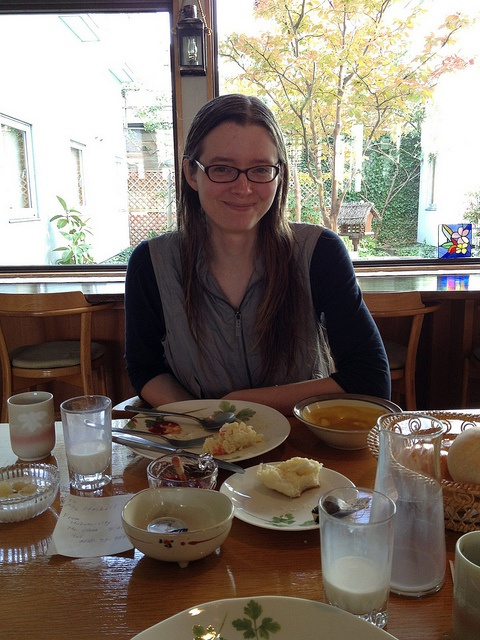Describe the objects in this image and their specific colors. I can see dining table in black, gray, and maroon tones, people in black, maroon, and brown tones, bowl in black, gray, maroon, and white tones, cup in black, gray, maroon, and darkgray tones, and bowl in black, gray, and olive tones in this image. 